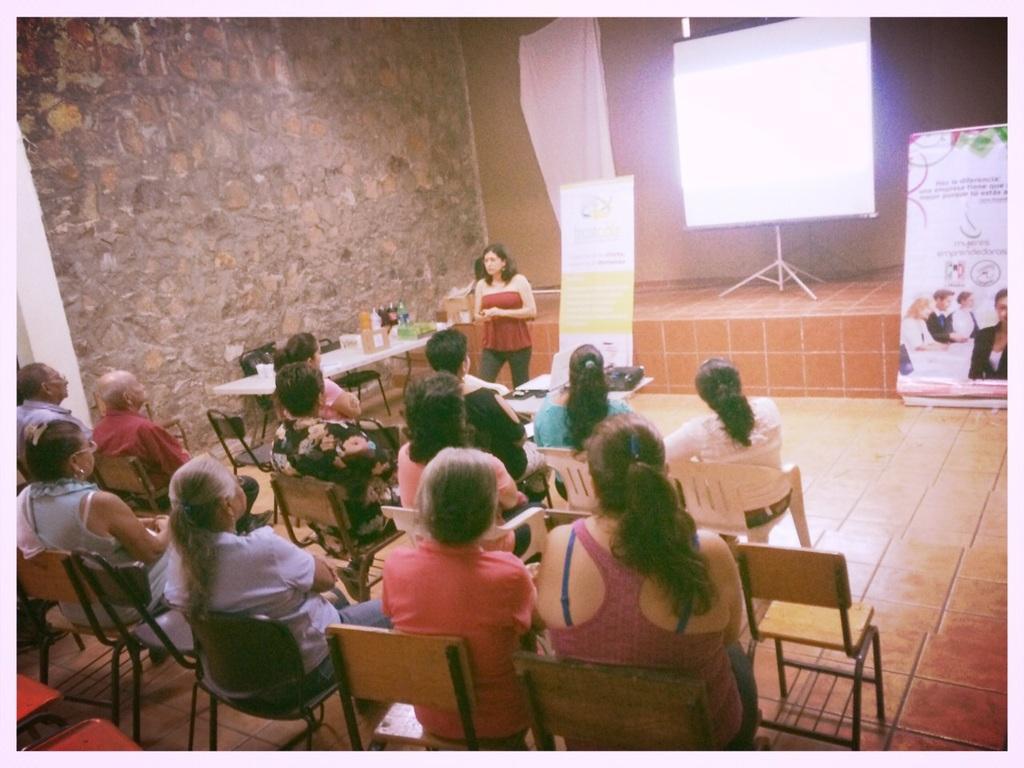In one or two sentences, can you explain what this image depicts? in a room people are seated on the chairs. in the front a person is standing and speaking. behind her there are 2 banners and a projector screen on the stage. at the right there is a table on which there are bottles. behind that there is a wall. 